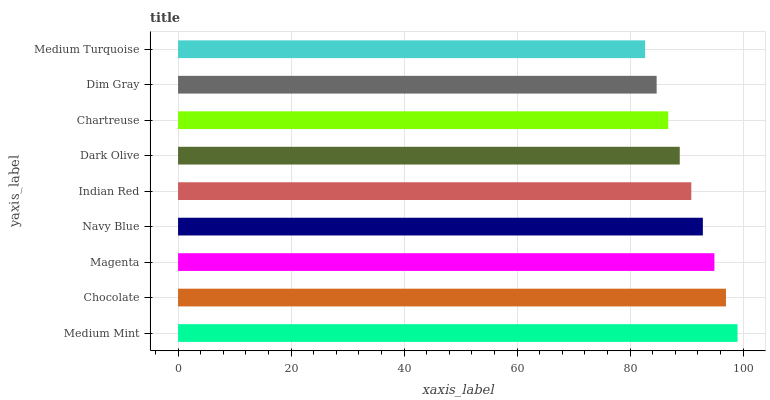Is Medium Turquoise the minimum?
Answer yes or no. Yes. Is Medium Mint the maximum?
Answer yes or no. Yes. Is Chocolate the minimum?
Answer yes or no. No. Is Chocolate the maximum?
Answer yes or no. No. Is Medium Mint greater than Chocolate?
Answer yes or no. Yes. Is Chocolate less than Medium Mint?
Answer yes or no. Yes. Is Chocolate greater than Medium Mint?
Answer yes or no. No. Is Medium Mint less than Chocolate?
Answer yes or no. No. Is Indian Red the high median?
Answer yes or no. Yes. Is Indian Red the low median?
Answer yes or no. Yes. Is Chocolate the high median?
Answer yes or no. No. Is Dark Olive the low median?
Answer yes or no. No. 